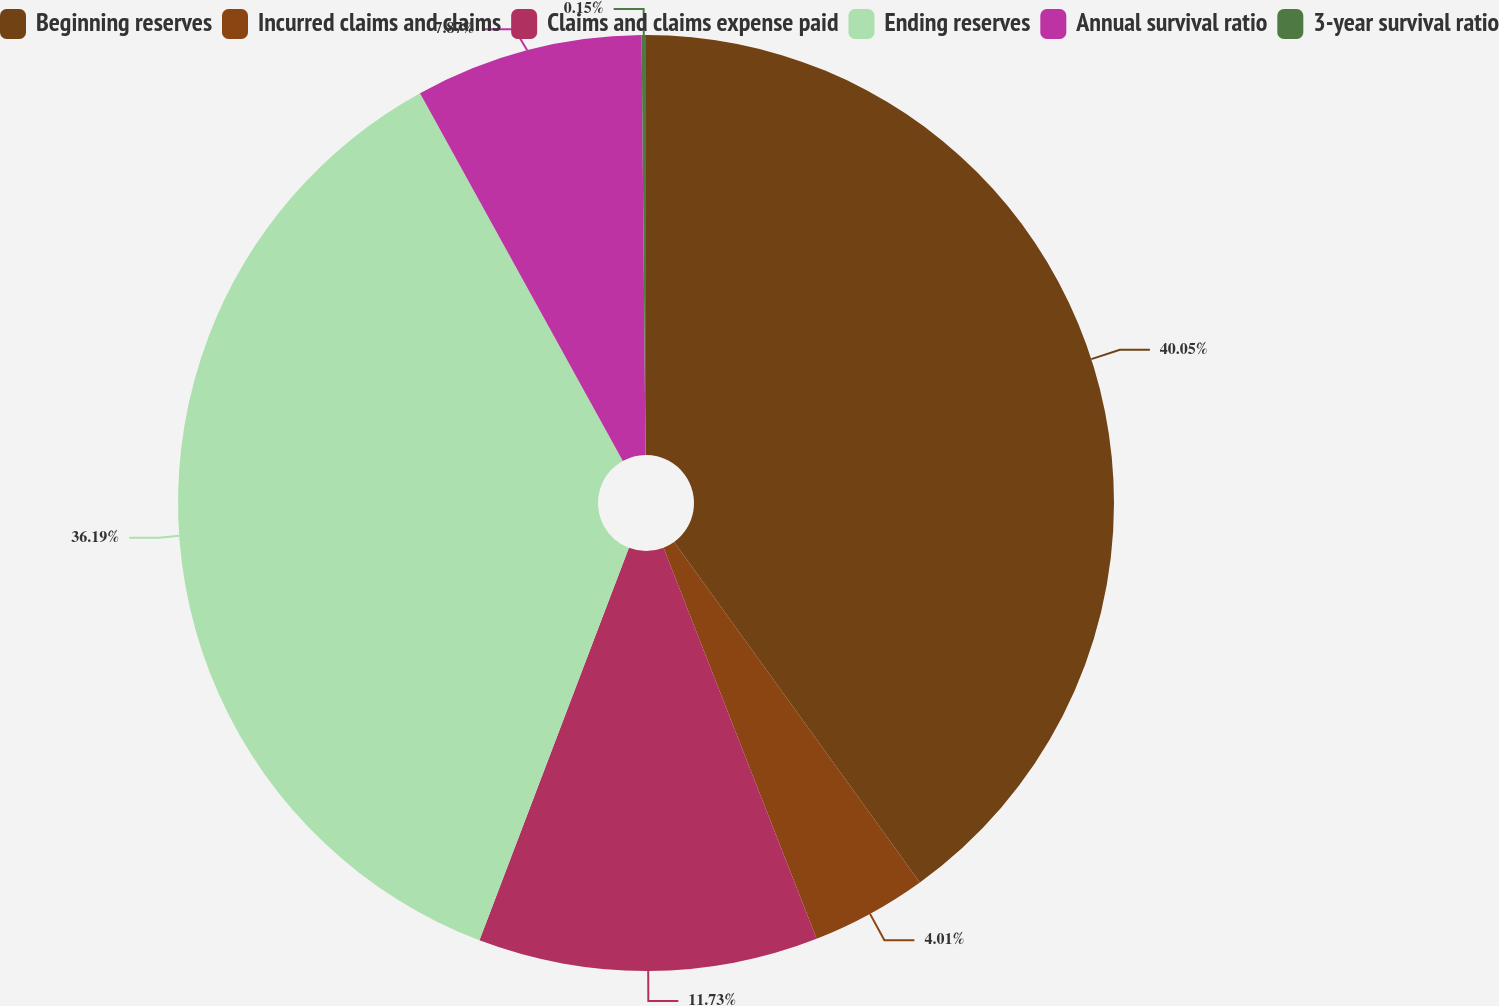Convert chart to OTSL. <chart><loc_0><loc_0><loc_500><loc_500><pie_chart><fcel>Beginning reserves<fcel>Incurred claims and claims<fcel>Claims and claims expense paid<fcel>Ending reserves<fcel>Annual survival ratio<fcel>3-year survival ratio<nl><fcel>40.05%<fcel>4.01%<fcel>11.73%<fcel>36.19%<fcel>7.87%<fcel>0.15%<nl></chart> 